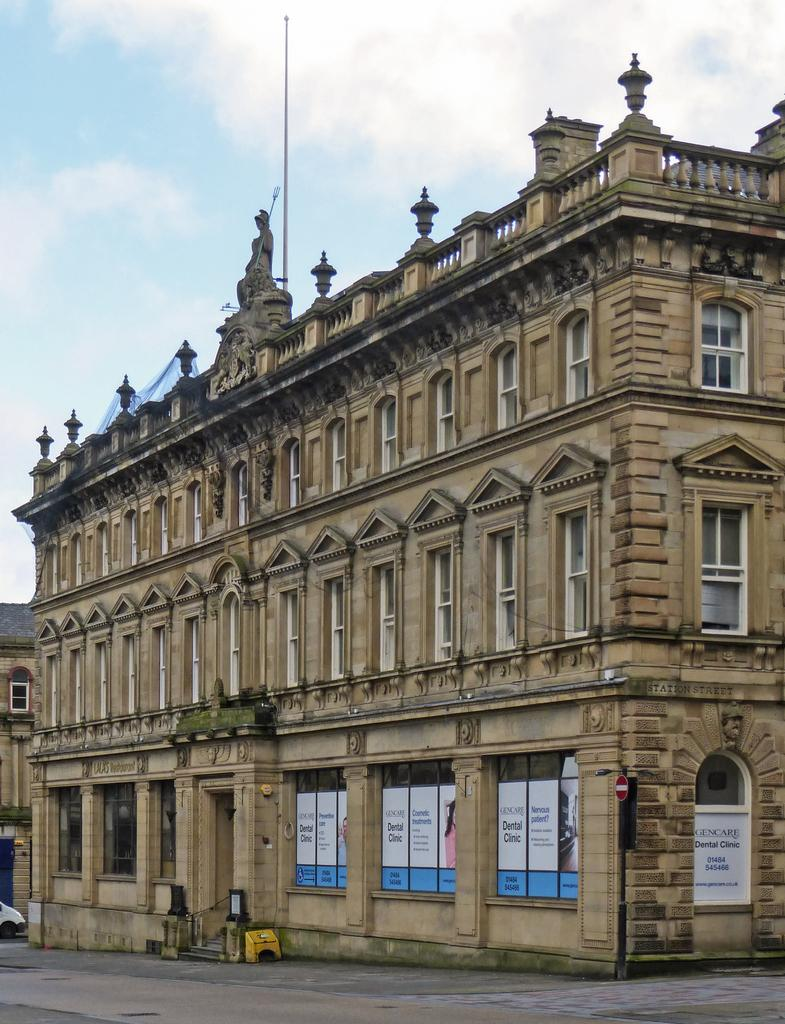What can be said about the size of the building in the image? The building is big. What is the color of the sky in the image? The sky is blue. How many kites are flying in the image? There are no kites present in the image. What type of brick is used to construct the building in the image? There is no information about the type of brick used to construct the building in the image. 